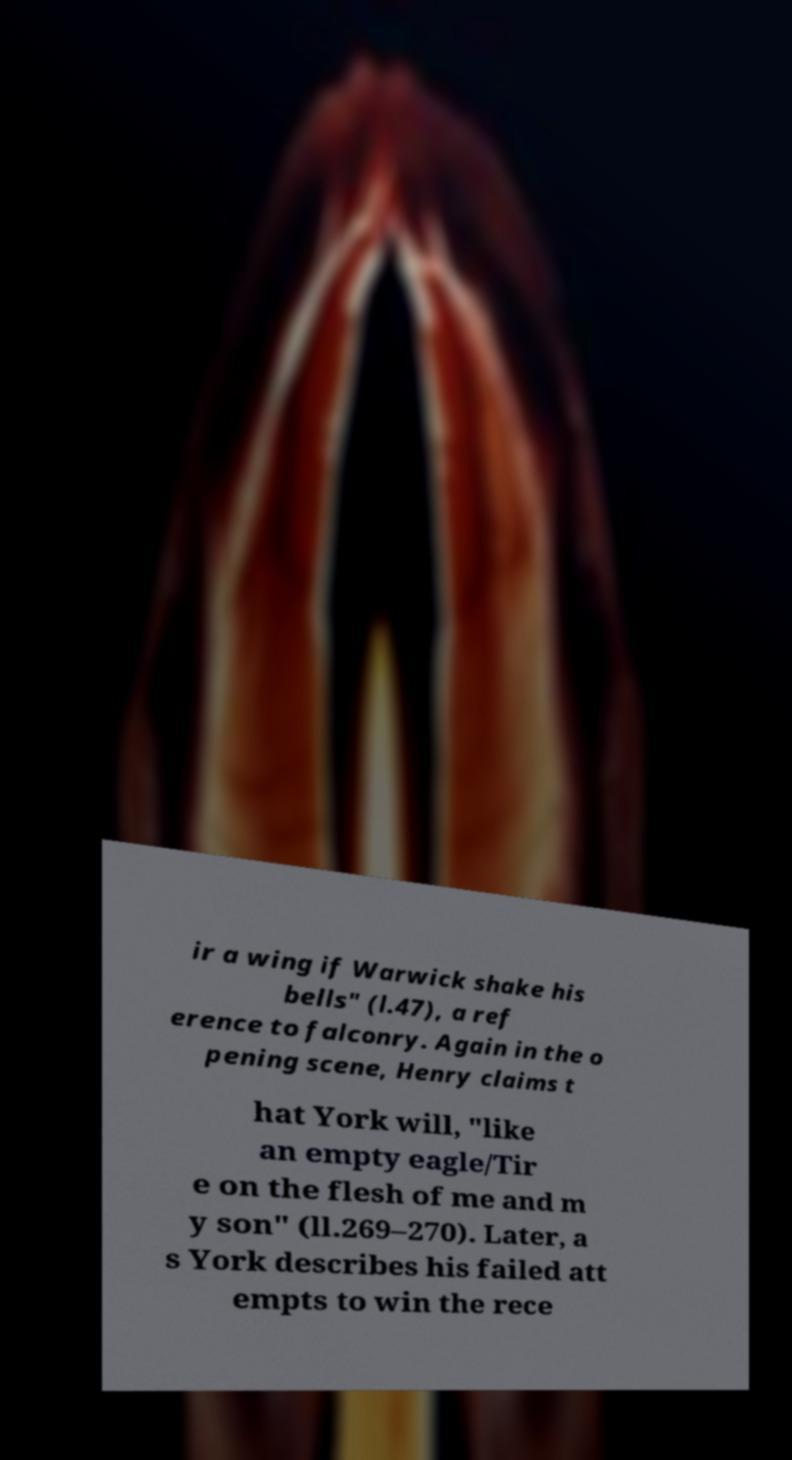I need the written content from this picture converted into text. Can you do that? ir a wing if Warwick shake his bells" (l.47), a ref erence to falconry. Again in the o pening scene, Henry claims t hat York will, "like an empty eagle/Tir e on the flesh of me and m y son" (ll.269–270). Later, a s York describes his failed att empts to win the rece 